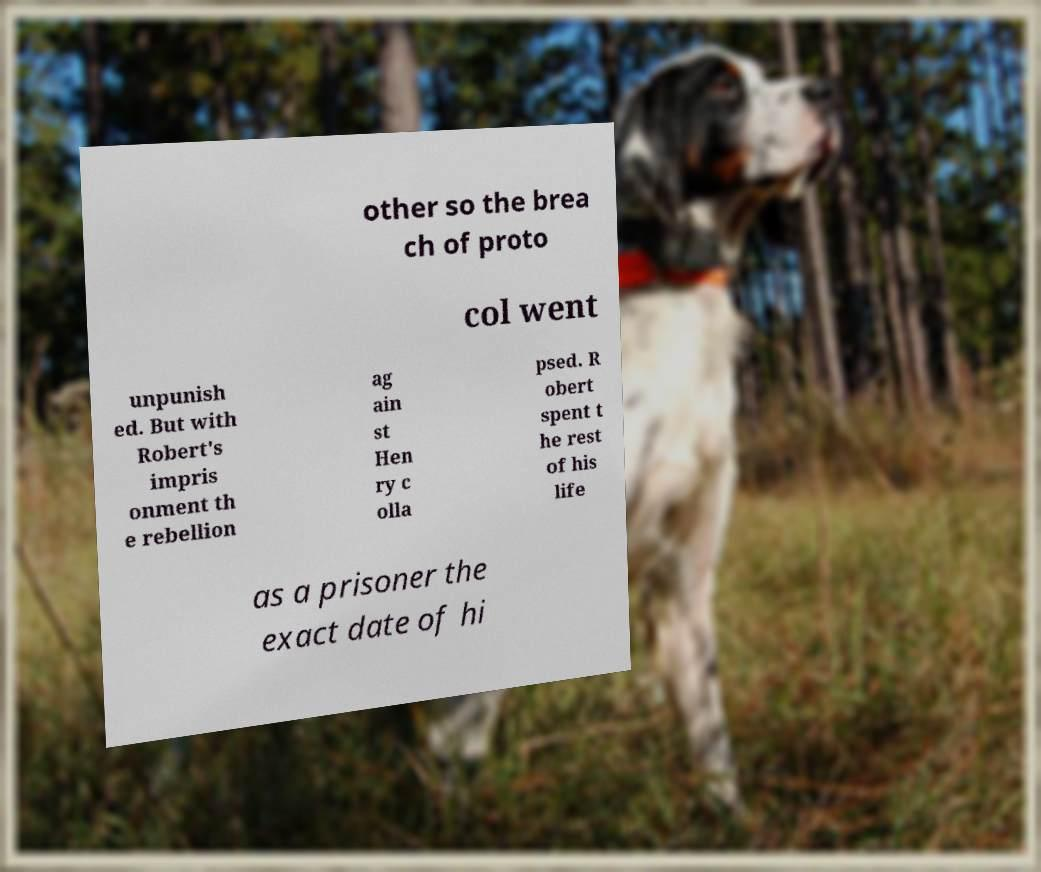I need the written content from this picture converted into text. Can you do that? other so the brea ch of proto col went unpunish ed. But with Robert's impris onment th e rebellion ag ain st Hen ry c olla psed. R obert spent t he rest of his life as a prisoner the exact date of hi 